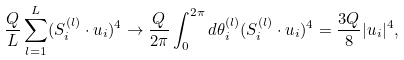Convert formula to latex. <formula><loc_0><loc_0><loc_500><loc_500>\frac { Q } { L } \sum _ { l = 1 } ^ { L } ( { S } _ { i } ^ { ( l ) } \cdot { u } _ { i } ) ^ { 4 } \to \frac { Q } { 2 \pi } \int _ { 0 } ^ { 2 \pi } d \theta _ { i } ^ { ( l ) } ( { S } _ { i } ^ { ( l ) } \cdot { u } _ { i } ) ^ { 4 } = \frac { 3 Q } { 8 } | { u } _ { i } | ^ { 4 } ,</formula> 